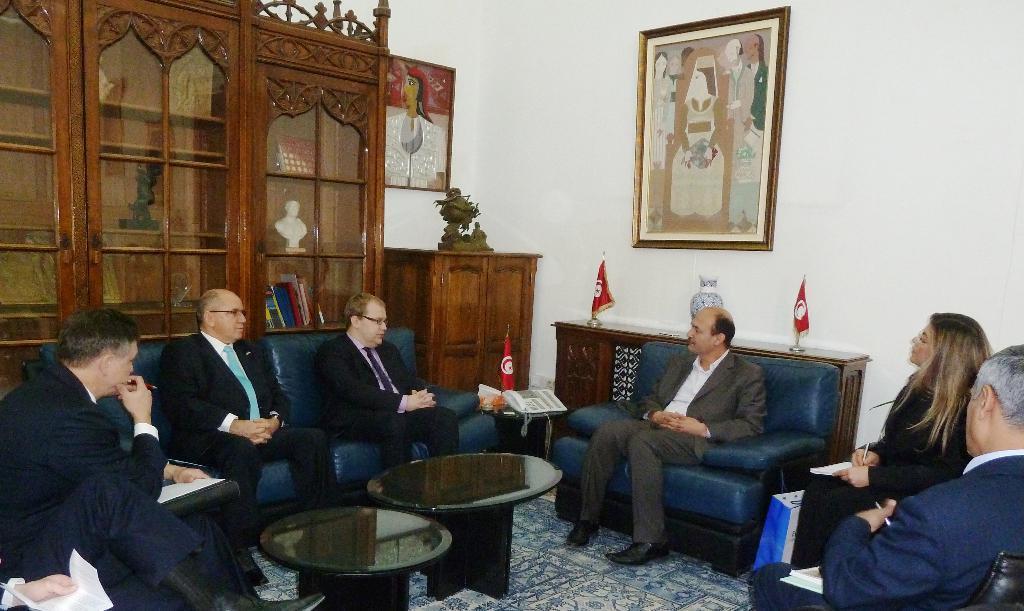In one or two sentences, can you explain what this image depicts? In this image I can see the group of people sitting in front of the teapoy. To the back of this person there are flags and a flower vase. in the back ground there is a frame attached to the wall and a cupboard. 